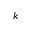<formula> <loc_0><loc_0><loc_500><loc_500>k</formula> 